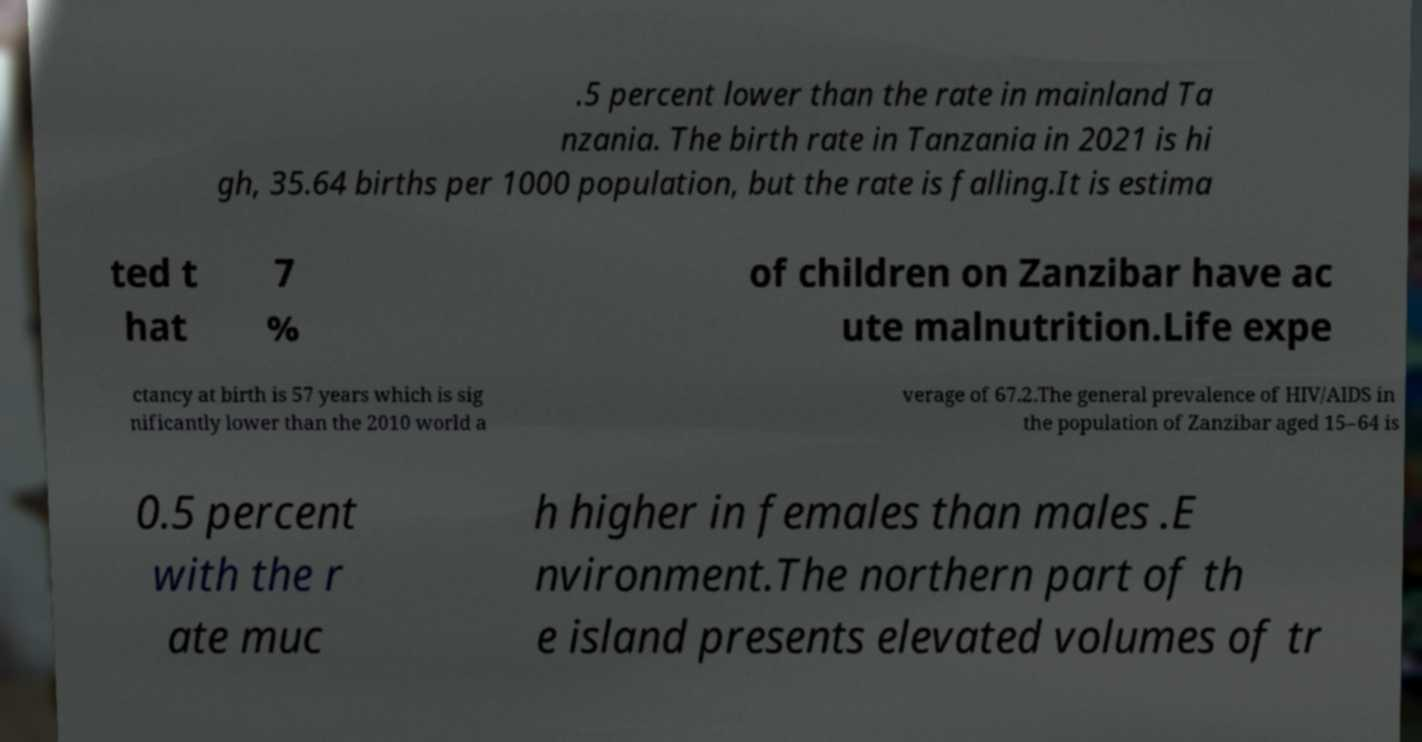Could you extract and type out the text from this image? .5 percent lower than the rate in mainland Ta nzania. The birth rate in Tanzania in 2021 is hi gh, 35.64 births per 1000 population, but the rate is falling.It is estima ted t hat 7 % of children on Zanzibar have ac ute malnutrition.Life expe ctancy at birth is 57 years which is sig nificantly lower than the 2010 world a verage of 67.2.The general prevalence of HIV/AIDS in the population of Zanzibar aged 15–64 is 0.5 percent with the r ate muc h higher in females than males .E nvironment.The northern part of th e island presents elevated volumes of tr 